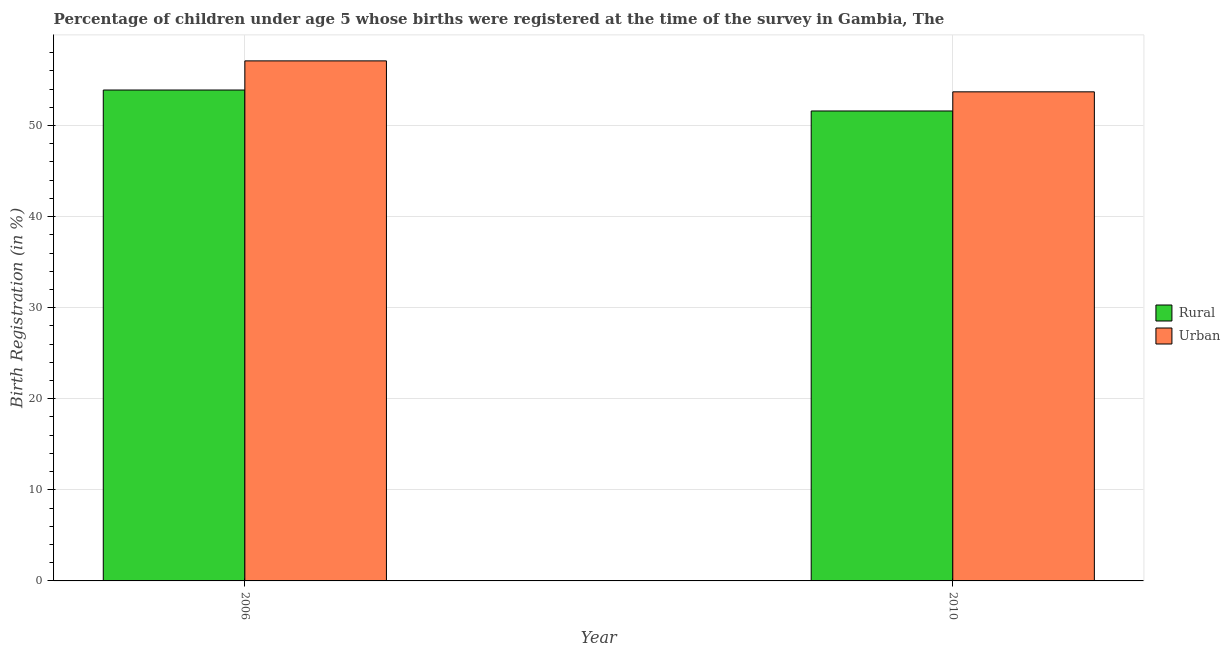How many different coloured bars are there?
Your answer should be very brief. 2. How many bars are there on the 1st tick from the left?
Your answer should be compact. 2. What is the label of the 1st group of bars from the left?
Provide a short and direct response. 2006. What is the rural birth registration in 2010?
Offer a terse response. 51.6. Across all years, what is the maximum urban birth registration?
Your response must be concise. 57.1. Across all years, what is the minimum urban birth registration?
Provide a succinct answer. 53.7. In which year was the rural birth registration maximum?
Your answer should be compact. 2006. In which year was the urban birth registration minimum?
Your response must be concise. 2010. What is the total urban birth registration in the graph?
Offer a very short reply. 110.8. What is the difference between the rural birth registration in 2006 and that in 2010?
Your answer should be compact. 2.3. What is the difference between the rural birth registration in 2006 and the urban birth registration in 2010?
Provide a succinct answer. 2.3. What is the average urban birth registration per year?
Ensure brevity in your answer.  55.4. What is the ratio of the rural birth registration in 2006 to that in 2010?
Your answer should be very brief. 1.04. Is the urban birth registration in 2006 less than that in 2010?
Make the answer very short. No. In how many years, is the urban birth registration greater than the average urban birth registration taken over all years?
Provide a short and direct response. 1. What does the 1st bar from the left in 2010 represents?
Your answer should be compact. Rural. What does the 1st bar from the right in 2006 represents?
Your answer should be very brief. Urban. How many bars are there?
Give a very brief answer. 4. Does the graph contain grids?
Offer a terse response. Yes. What is the title of the graph?
Make the answer very short. Percentage of children under age 5 whose births were registered at the time of the survey in Gambia, The. Does "Males" appear as one of the legend labels in the graph?
Your answer should be compact. No. What is the label or title of the X-axis?
Your answer should be compact. Year. What is the label or title of the Y-axis?
Give a very brief answer. Birth Registration (in %). What is the Birth Registration (in %) of Rural in 2006?
Provide a succinct answer. 53.9. What is the Birth Registration (in %) of Urban in 2006?
Keep it short and to the point. 57.1. What is the Birth Registration (in %) in Rural in 2010?
Your answer should be very brief. 51.6. What is the Birth Registration (in %) of Urban in 2010?
Offer a very short reply. 53.7. Across all years, what is the maximum Birth Registration (in %) in Rural?
Provide a succinct answer. 53.9. Across all years, what is the maximum Birth Registration (in %) of Urban?
Provide a succinct answer. 57.1. Across all years, what is the minimum Birth Registration (in %) in Rural?
Ensure brevity in your answer.  51.6. Across all years, what is the minimum Birth Registration (in %) in Urban?
Make the answer very short. 53.7. What is the total Birth Registration (in %) of Rural in the graph?
Give a very brief answer. 105.5. What is the total Birth Registration (in %) in Urban in the graph?
Provide a succinct answer. 110.8. What is the average Birth Registration (in %) in Rural per year?
Offer a very short reply. 52.75. What is the average Birth Registration (in %) of Urban per year?
Keep it short and to the point. 55.4. In the year 2010, what is the difference between the Birth Registration (in %) of Rural and Birth Registration (in %) of Urban?
Provide a succinct answer. -2.1. What is the ratio of the Birth Registration (in %) in Rural in 2006 to that in 2010?
Make the answer very short. 1.04. What is the ratio of the Birth Registration (in %) in Urban in 2006 to that in 2010?
Ensure brevity in your answer.  1.06. What is the difference between the highest and the second highest Birth Registration (in %) in Rural?
Keep it short and to the point. 2.3. What is the difference between the highest and the lowest Birth Registration (in %) of Rural?
Keep it short and to the point. 2.3. 